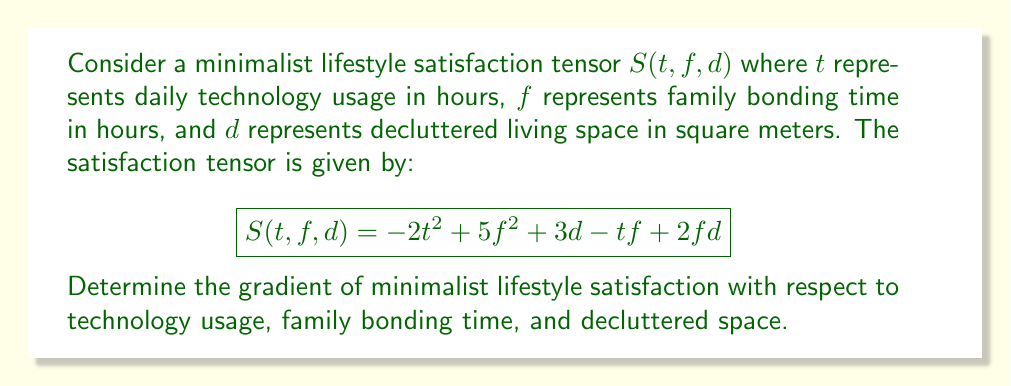Teach me how to tackle this problem. To find the gradient of the minimalist lifestyle satisfaction tensor, we need to calculate the partial derivatives with respect to each variable:

1. Partial derivative with respect to $t$ (technology usage):
   $$\frac{\partial S}{\partial t} = -4t - f$$

2. Partial derivative with respect to $f$ (family bonding time):
   $$\frac{\partial S}{\partial f} = 10f - t + 2d$$

3. Partial derivative with respect to $d$ (decluttered space):
   $$\frac{\partial S}{\partial d} = 3 + 2f$$

The gradient is a vector-valued function that combines these partial derivatives:

$$\nabla S(t, f, d) = \left(\frac{\partial S}{\partial t}, \frac{\partial S}{\partial f}, \frac{\partial S}{\partial d}\right)$$

Therefore, the gradient of minimalist lifestyle satisfaction is:

$$\nabla S(t, f, d) = (-4t - f, 10f - t + 2d, 3 + 2f)$$
Answer: $\nabla S(t, f, d) = (-4t - f, 10f - t + 2d, 3 + 2f)$ 